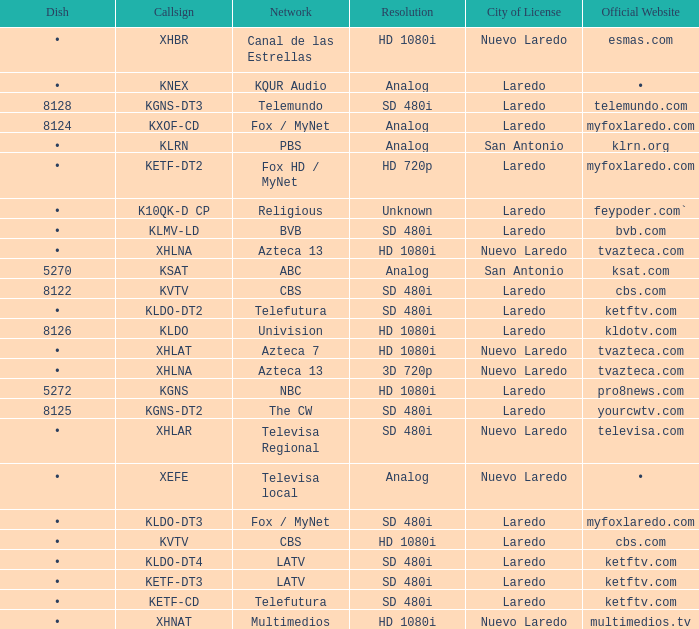Name the official website which has dish of • and callsign of kvtv Cbs.com. 